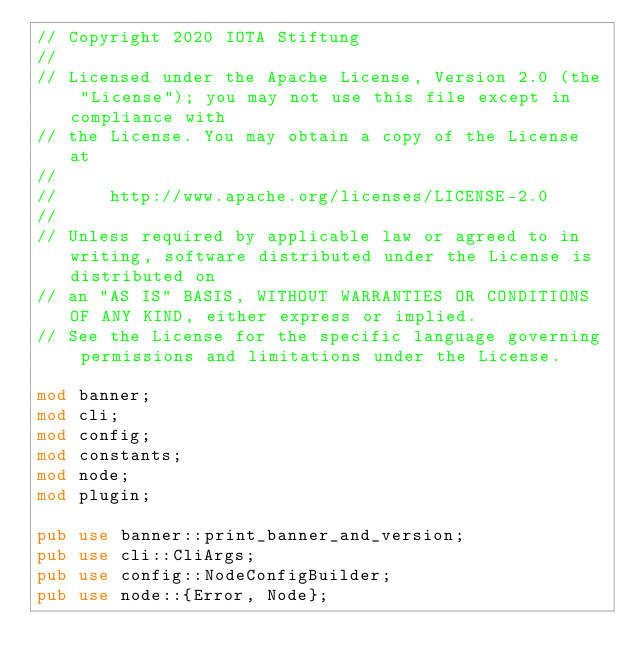Convert code to text. <code><loc_0><loc_0><loc_500><loc_500><_Rust_>// Copyright 2020 IOTA Stiftung
//
// Licensed under the Apache License, Version 2.0 (the "License"); you may not use this file except in compliance with
// the License. You may obtain a copy of the License at
//
//     http://www.apache.org/licenses/LICENSE-2.0
//
// Unless required by applicable law or agreed to in writing, software distributed under the License is distributed on
// an "AS IS" BASIS, WITHOUT WARRANTIES OR CONDITIONS OF ANY KIND, either express or implied.
// See the License for the specific language governing permissions and limitations under the License.

mod banner;
mod cli;
mod config;
mod constants;
mod node;
mod plugin;

pub use banner::print_banner_and_version;
pub use cli::CliArgs;
pub use config::NodeConfigBuilder;
pub use node::{Error, Node};
</code> 